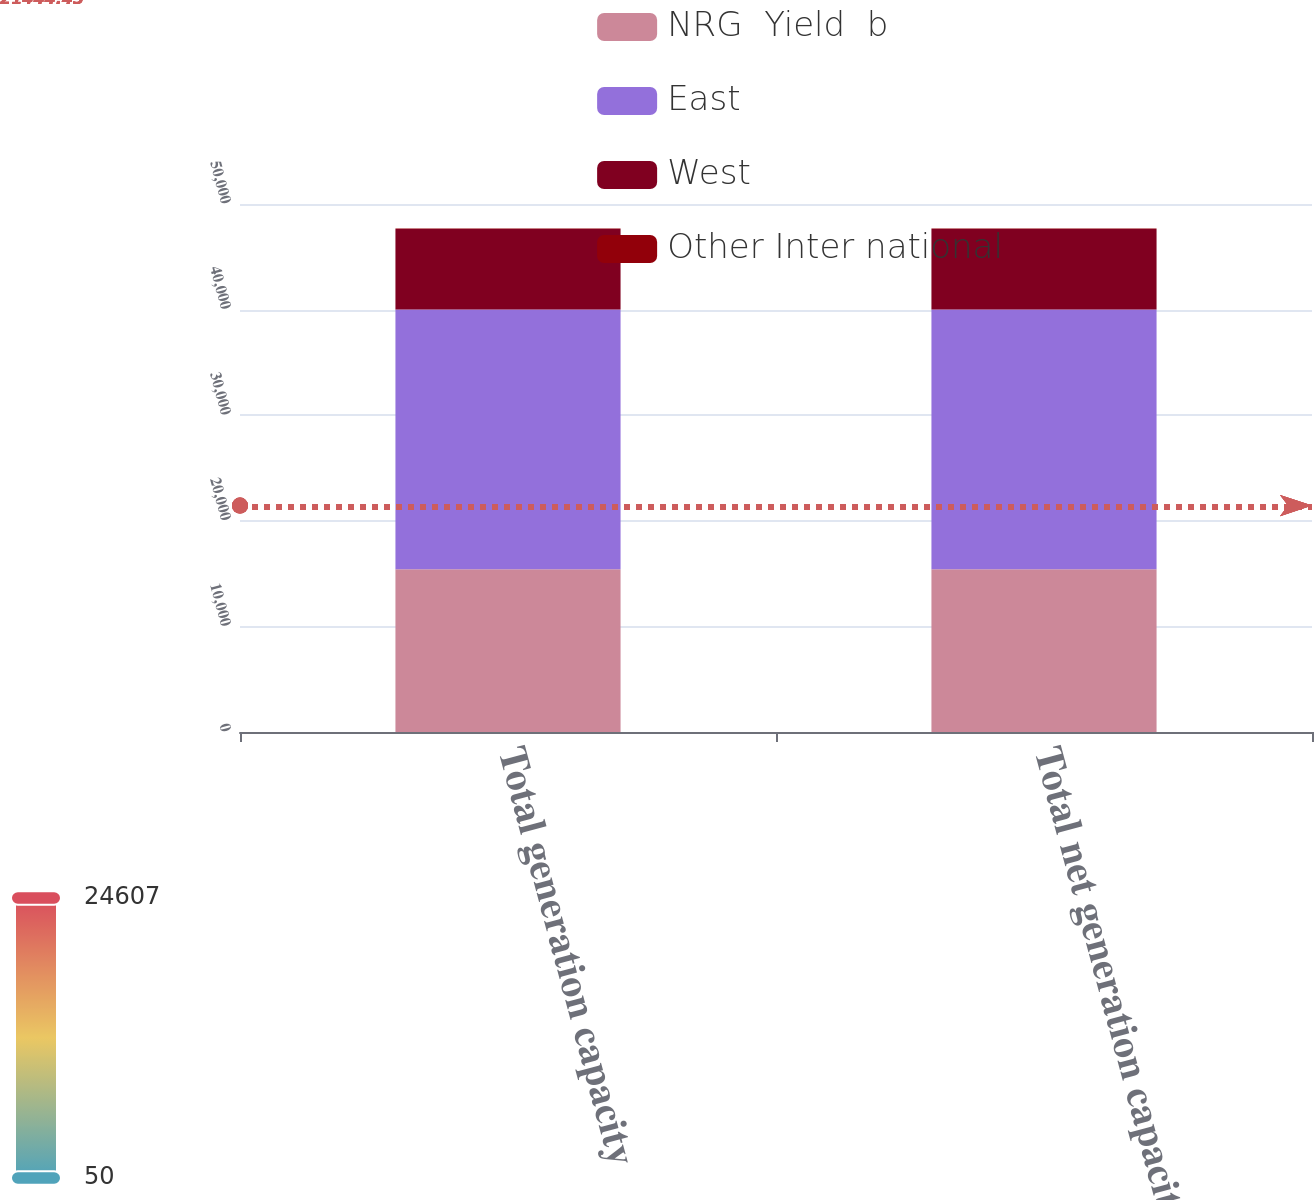Convert chart. <chart><loc_0><loc_0><loc_500><loc_500><stacked_bar_chart><ecel><fcel>Total generation capacity<fcel>Total net generation capacity<nl><fcel>NRG  Yield  b<fcel>15412<fcel>15412<nl><fcel>East<fcel>24607<fcel>24607<nl><fcel>West<fcel>7617<fcel>7617<nl><fcel>Other Inter national<fcel>50<fcel>50<nl></chart> 